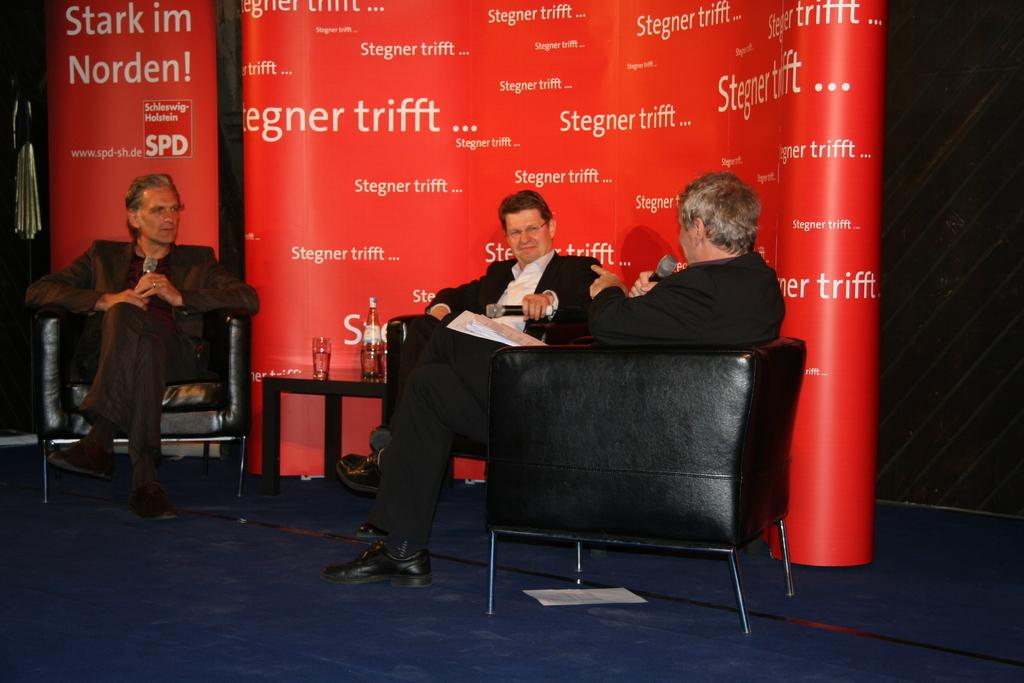How many people are in the image? There are three men in the image. What are the men doing in the image? The men are sitting on chairs and holding microphones in their hands. What is written on the microphones? The microphones have the words "Stregner trifft" written on them. Can you see a glove on any of the men's hands in the image? No, there are no gloves visible on any of the men's hands in the image. What type of machine is being operated by the men in the image? There is no machine present in the image; the men are holding microphones. 